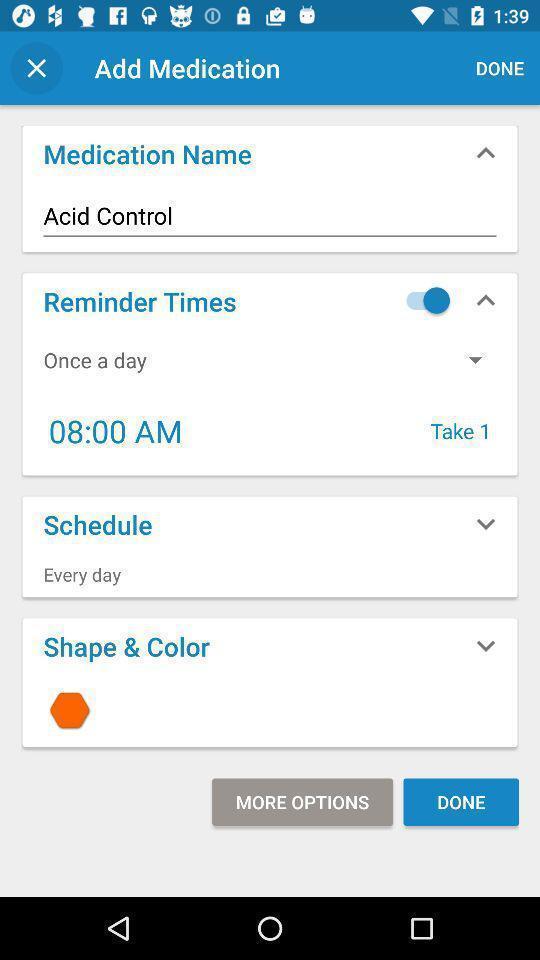Tell me about the visual elements in this screen capture. Page shows the various medication setting options to setup. 